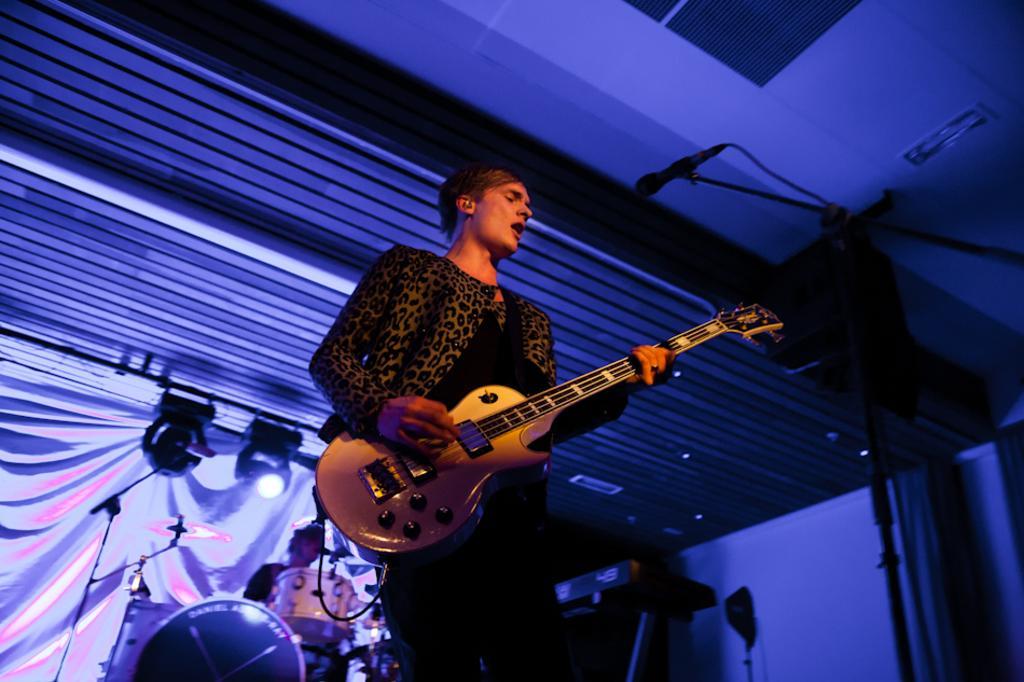Describe this image in one or two sentences. In the image we can see there is a man who is holding a guitar in his hand and at the back there is a man who is playing a drum set. 